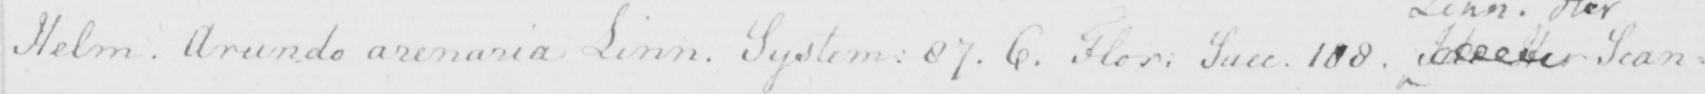Can you tell me what this handwritten text says? Helm . Arundo arenaria Linn . System :  87 . 6 . Flor :  Suec . 108 .  <gap/>  Scan= 